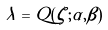Convert formula to latex. <formula><loc_0><loc_0><loc_500><loc_500>\lambda = Q ( \zeta ; \alpha , \beta )</formula> 